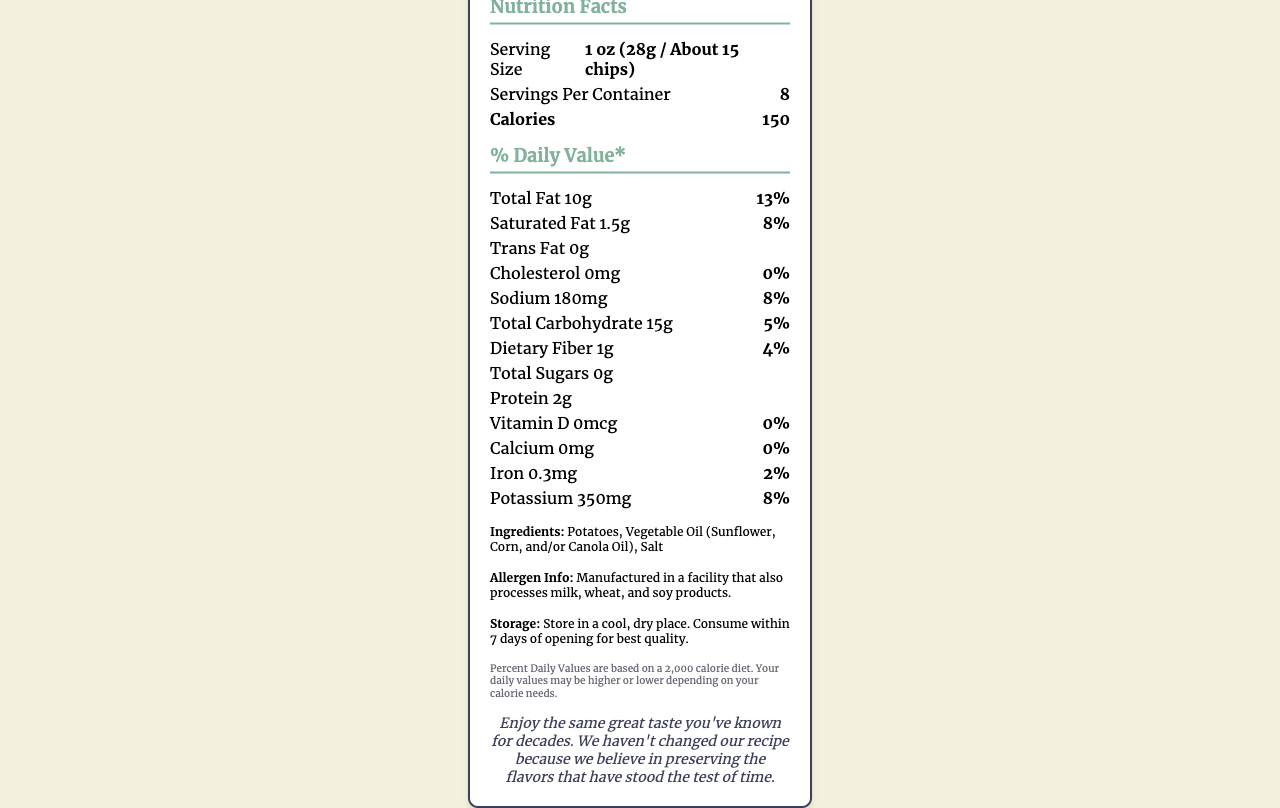what is the serving size for Classic Potato Chips? The serving size is clearly listed in the document as "1 oz (28g / About 15 chips)".
Answer: 1 oz (28g / About 15 chips) how many calories are there per serving? The document states that there are 150 calories per serving.
Answer: 150 how much saturated fat is in a serving of Classic Potato Chips? The document lists the amount of saturated fat as "1.5g".
Answer: 1.5g which ingredient is listed first in the ingredient list? The first ingredient listed is "Potatoes".
Answer: Potatoes is there any cholesterol in a serving? The document indicates that there is "0mg" of cholesterol in a serving.
Answer: No how many servings are there per container? The document specifies that there are "8" servings per container.
Answer: 8 how much protein is in a serving of Classic Potato Chips? The labeled document states that there are "2g" of protein per serving.
Answer: 2g what percentage of the daily value of sodium does one serving contain? The document states that one serving contains 8% of the daily value for sodium.
Answer: 8% what many types of oils are listed in the ingredients? A. One B. Two C. Three D. Four The ingredients list shows "Vegetable Oil (Sunflower, Corn, and/or Canola Oil)", indicating three types of oils.
Answer: C. Three which of the following nutrients does Classic Potato Chips contain the most of? I. Sodium II. Protein III. Dietary Fiber IV. Iron Sodium is listed as 180mg, which is more compared to the amounts of protein, dietary fiber, and iron listed.
Answer: I. Sodium does the Classic Potato Chips package mention any allergen information? There is a note saying "Manufactured in a facility that also processes milk, wheat, and soy products."
Answer: Yes does the product have any trans fat? The document lists "0g" of trans fat.
Answer: No summarize the key nutritional information of Classic Potato Chips. This summary captures the essential nutritional details, ingredients, and important notices from the document.
Answer: The Classic Potato Chips from Traditional Snacks Co. have a serving size of 1 oz (28g / About 15 chips) and 150 calories per serving. Key nutrients per serving include 10g of total fat (13% DV), 1.5g saturated fat (8% DV), 0g trans fat, 0mg cholesterol, 180mg sodium (8% DV), 15g total carbohydrates (5% DV), 1g dietary fiber (4% DV), 0g total sugars, 2g protein, 0mcg vitamin D, 0mg calcium, 0.3mg iron (2% DV), and 350mg potassium (8% DV). The ingredients include Potatoes, Vegetable Oil, and Salt, with allergen info indicating processing in a facility handling milk, wheat, and soy products. The product emphasizes preserving its traditional recipe. what is the manufacturing address of Traditional Snacks Co.? The document does not mention the manufacturing address specifically in the visible information.
Answer: Cannot be determined 